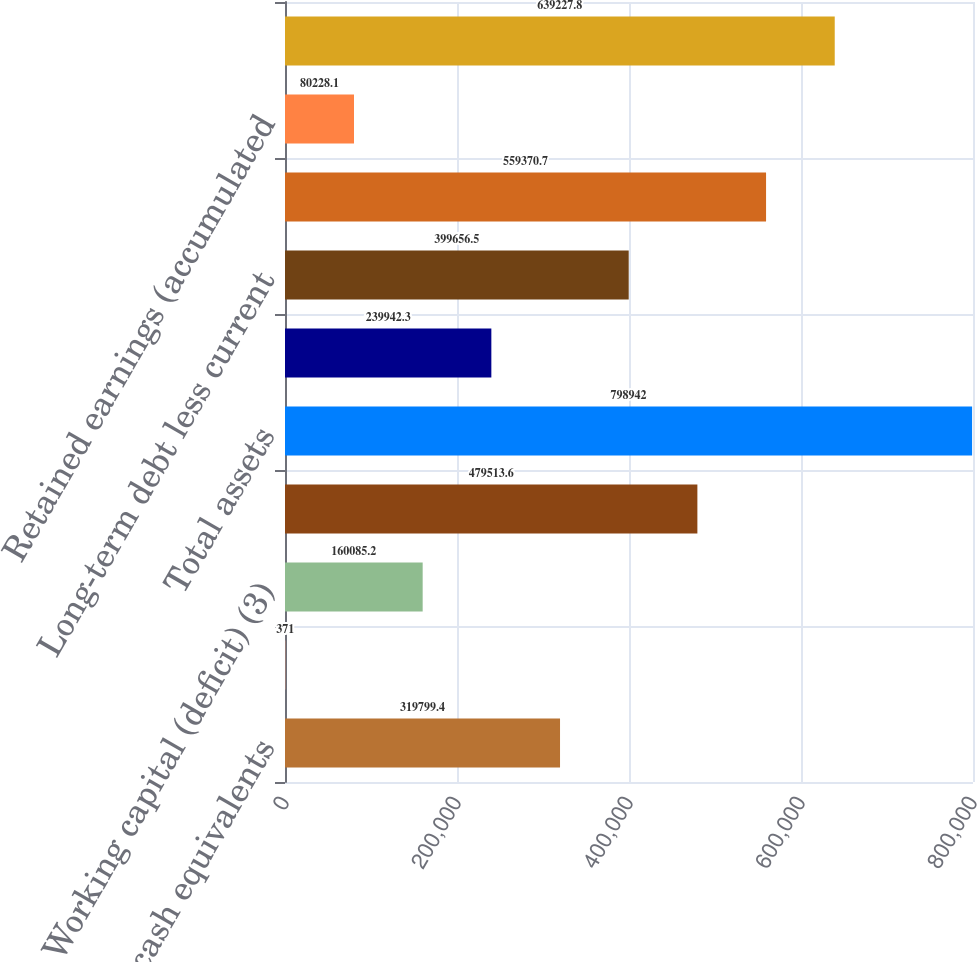Convert chart to OTSL. <chart><loc_0><loc_0><loc_500><loc_500><bar_chart><fcel>Cash and cash equivalents<fcel>Restricted cash<fcel>Working capital (deficit) (3)<fcel>Property plant and equipment<fcel>Total assets<fcel>Deferred revenue<fcel>Long-term debt less current<fcel>Additional paid in capital<fcel>Retained earnings (accumulated<fcel>Total stockholders' equity<nl><fcel>319799<fcel>371<fcel>160085<fcel>479514<fcel>798942<fcel>239942<fcel>399656<fcel>559371<fcel>80228.1<fcel>639228<nl></chart> 